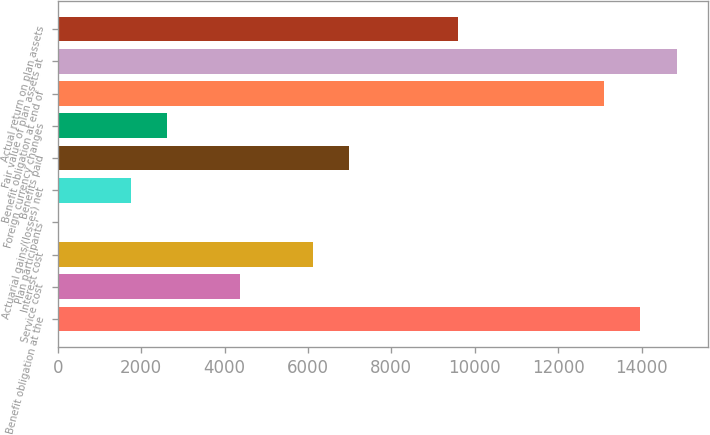Convert chart to OTSL. <chart><loc_0><loc_0><loc_500><loc_500><bar_chart><fcel>Benefit obligation at the<fcel>Service cost<fcel>Interest cost<fcel>Plan participants'<fcel>Actuarial gains/(losses) net<fcel>Benefits paid<fcel>Foreign currency changes<fcel>Benefit obligation at end of<fcel>Fair value of plan assets at<fcel>Actual return on plan assets<nl><fcel>13969<fcel>4366<fcel>6112<fcel>1<fcel>1747<fcel>6985<fcel>2620<fcel>13096<fcel>14842<fcel>9604<nl></chart> 